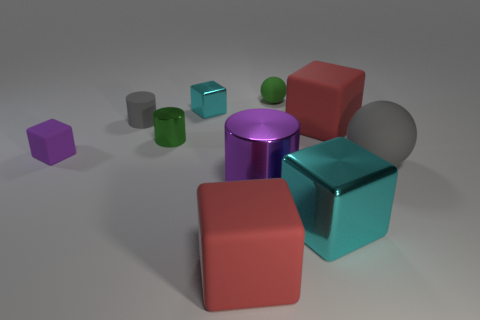Could you describe the texture differences between the objects in the foreground and background? Certainly, the objects in the foreground like the red cube and the purple cylinder have smoother and more reflective surfaces indicating a possibly metallic texture. In contrast, the more distant green cube and the smaller purple block appear to have a matte finish, suggestive of a rubbery or plastic material. 